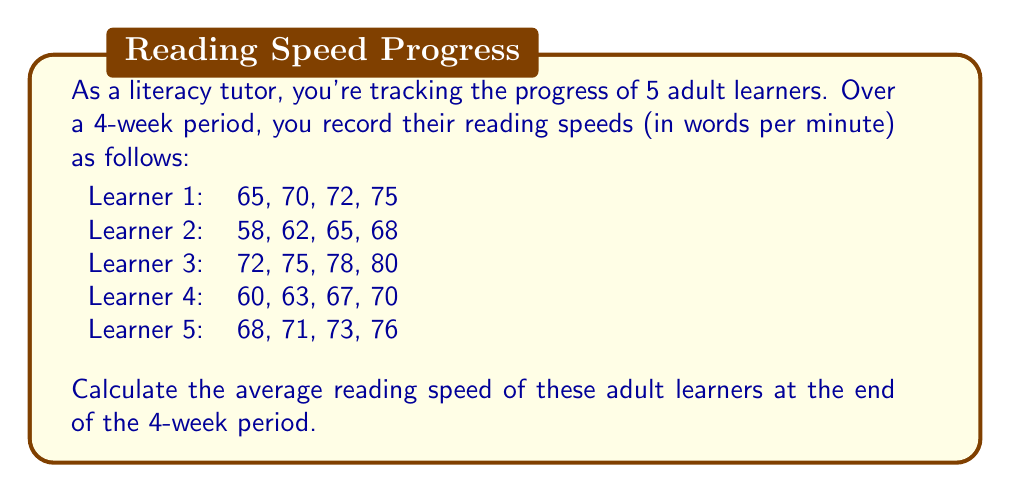Solve this math problem. To calculate the average reading speed of the adult learners at the end of the 4-week period, we'll follow these steps:

1. Identify the final reading speed for each learner (Week 4):
   Learner 1: 75 wpm
   Learner 2: 68 wpm
   Learner 3: 80 wpm
   Learner 4: 70 wpm
   Learner 5: 76 wpm

2. Sum up the final reading speeds:
   $$ \text{Total} = 75 + 68 + 80 + 70 + 76 = 369 \text{ wpm} $$

3. Count the number of learners:
   $$ n = 5 $$

4. Calculate the average using the formula:
   $$ \text{Average} = \frac{\text{Sum of values}}{\text{Number of values}} $$

   $$ \text{Average} = \frac{369}{5} = 73.8 \text{ wpm} $$

Therefore, the average reading speed of the adult learners at the end of the 4-week period is 73.8 words per minute.
Answer: 73.8 wpm 